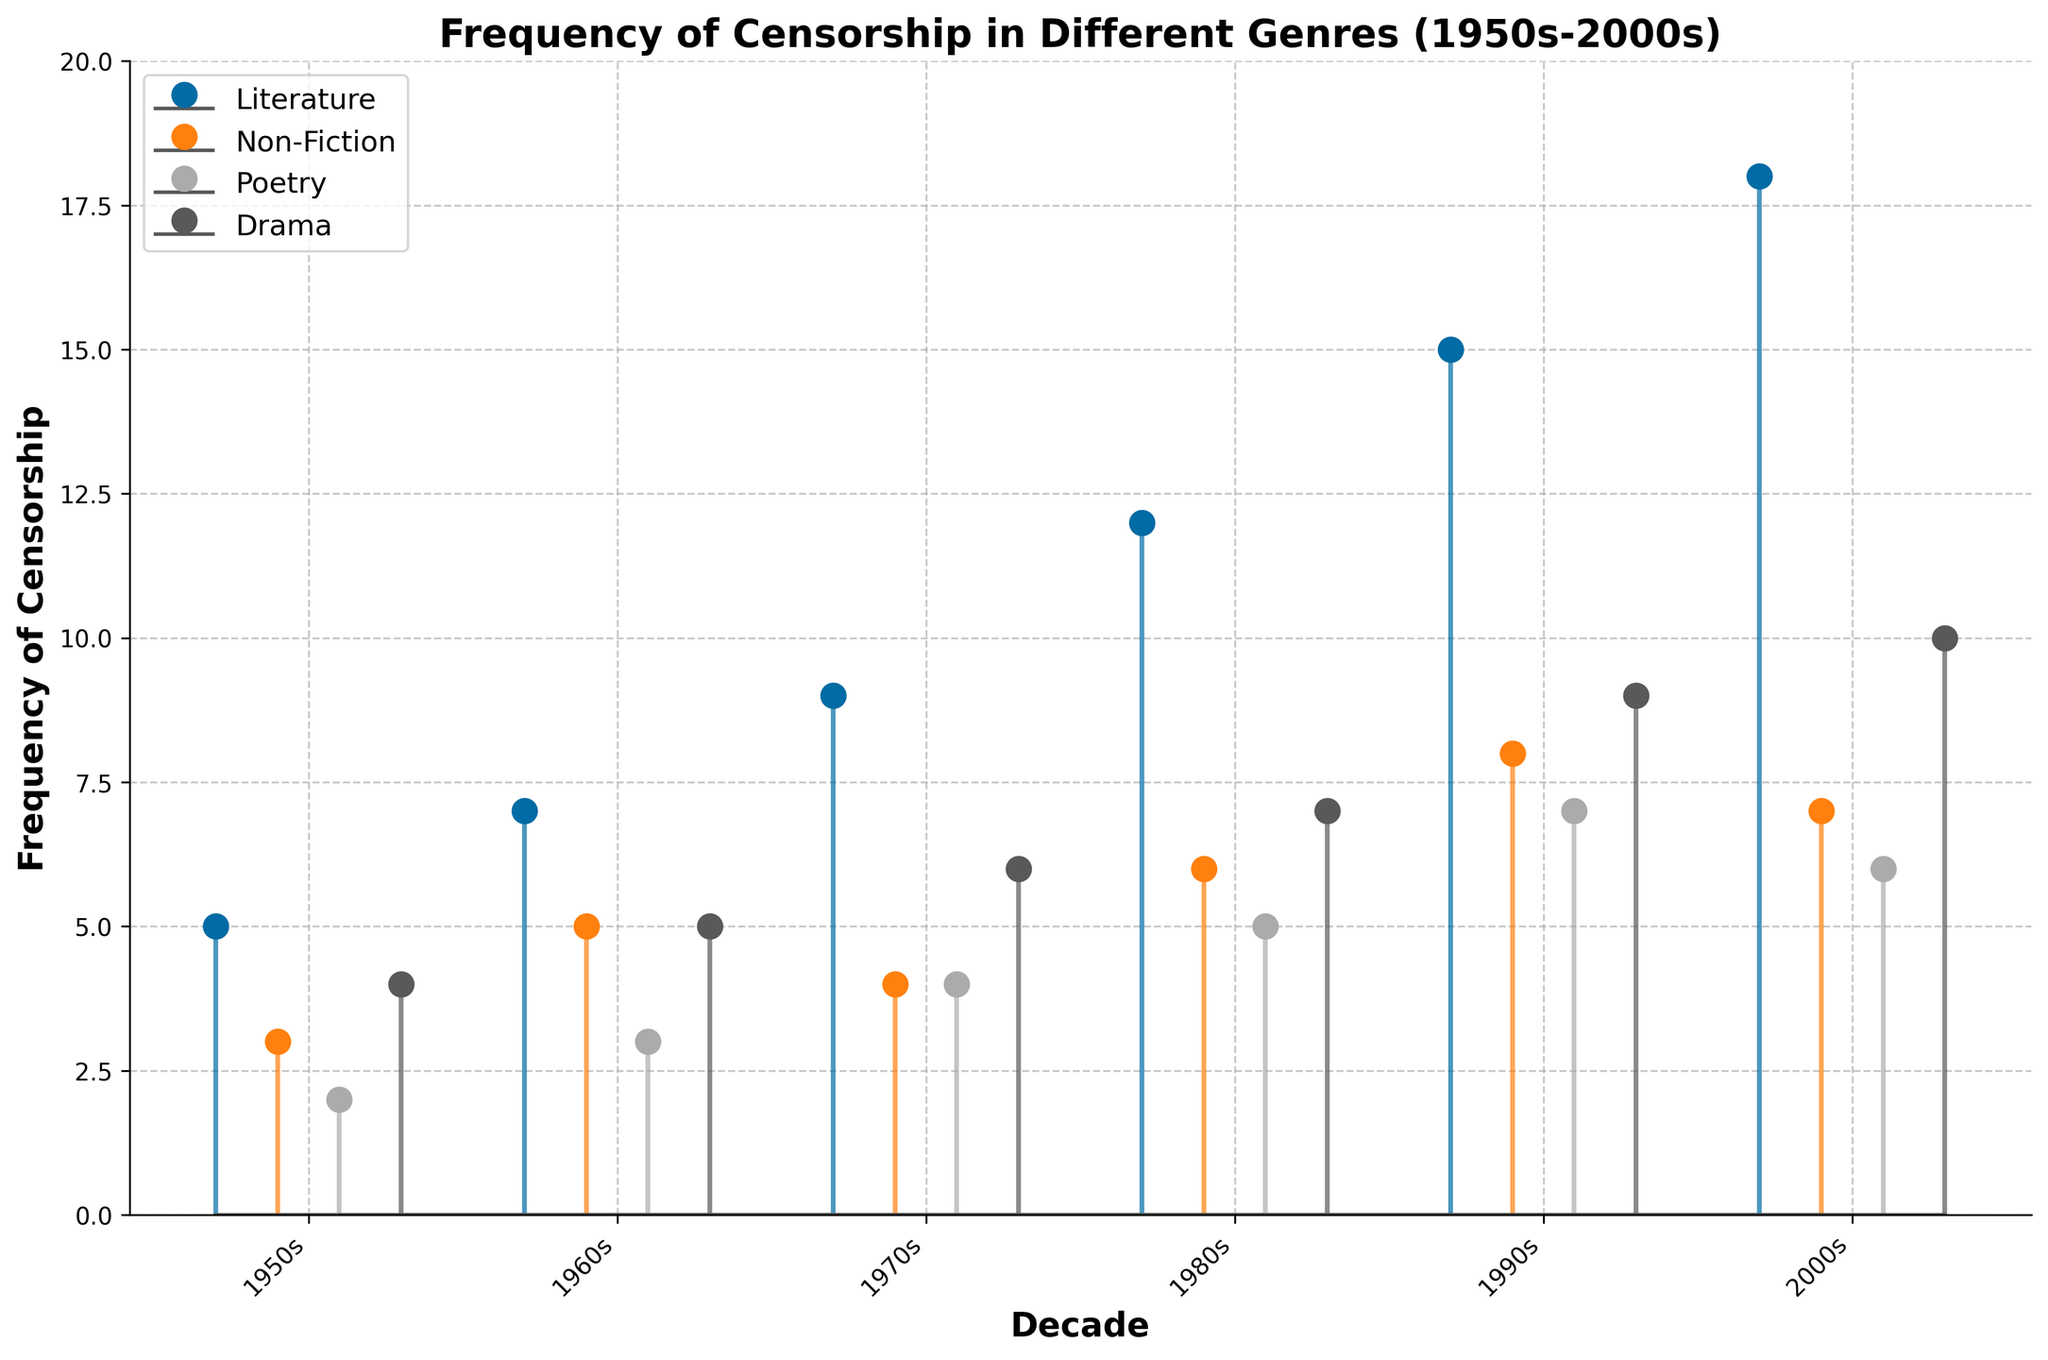What genre had the highest frequency of censorship in the 2000s? To determine the genre with the highest frequency of censorship in the 2000s, look at the marks on the y-axis corresponding to each genre for the 2000s. Literature has the highest mark at 18.
Answer: Literature During which decade did Non-Fiction experience its highest frequency of censorship? Check the heights of the Non-Fiction markers across all decades. The highest mark for Non-Fiction is in the 1990s, with a frequency of 8.
Answer: 1990s Compare the frequency of censorship for Poetry and Drama in the 1970s. Which had more, and by how much? Look at the y values for Poetry and Drama in the 1970s. Poetry had a frequency of 4, and Drama had 6. The difference between the two is 6 - 4 = 2, with Drama having more.
Answer: Drama by 2 Which decade saw the most significant increase in censorship frequency for Literature? To find the most significant increase, look at the change in the frequency values for Literature between consecutive decades. The change from the 1980s (12) to the 1990s (15) is 3, but from the 1990s (15) to the 2000s (18), it is also 3. The most significant single increase is between these periods.
Answer: 1980s–1990s or 1990s–2000s (both increased by 3) What is the overall trend observed in the censorship frequency for all genres from the 1950s to the 2000s? The overall trend can be observed by noting the general upward movement of the markers over time for all genres. All genres exhibit an increasing trend in censorship frequency from the 1950s to the 2000s.
Answer: Increasing trend How many times did Non-Fiction have a lower censorship frequency compared to the previous decade? Check each decade's frequencies for Non-Fiction and compare them with the previous decade. Frequency decreases from the 1950s (3) to the 1960s (5), increases from the 1960s to the 1970s (4), then increases from the 1970s to the 1980s (6), and decreases again. Two decreases occurred.
Answer: 2 times What is the mean frequency of censorship for Drama across all decades? Calculate the mean by summing the frequencies for Drama and dividing by the number of decades: 
(4 + 5 + 6 + 7 + 9 + 10) / 6 = 41 / 6 ≈ 6.83.
Answer: 6.83 What is the difference in total censorship frequency between the 1950s and the 2000s for all genres combined? Sum the frequencies for all genres in the 1950s and the 2000s and calculate the difference:
- 1950s: 5 + 3 + 2 + 4 = 14
- 2000s: 18 + 7 + 6 + 10 = 41
Difference: 41 - 14 = 27.
Answer: 27 